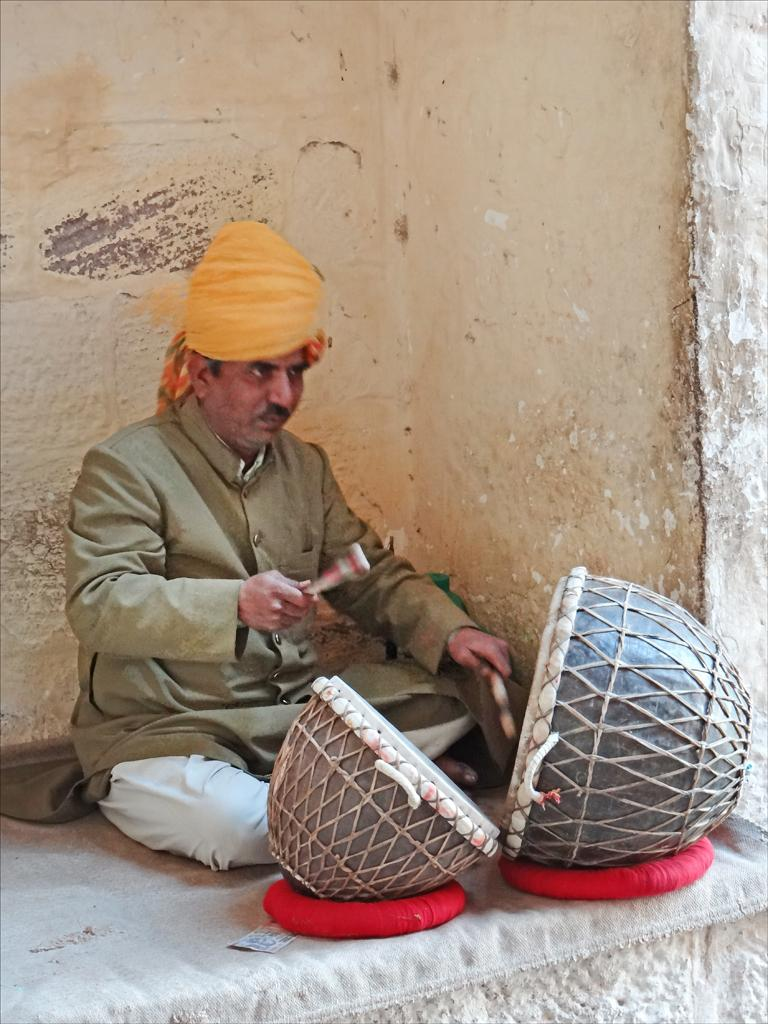Who is the main subject in the image? There is a man in the image. What is the man sitting on? The man is sitting on a cloth. Where is the man located in the image? The man is on a platform. What is the man doing in the image? The man is playing drums with sticks. What can be seen in the background of the image? There is a wall in the image. What type of growth can be seen on the wall in the image? There is no growth visible on the wall in the image. 